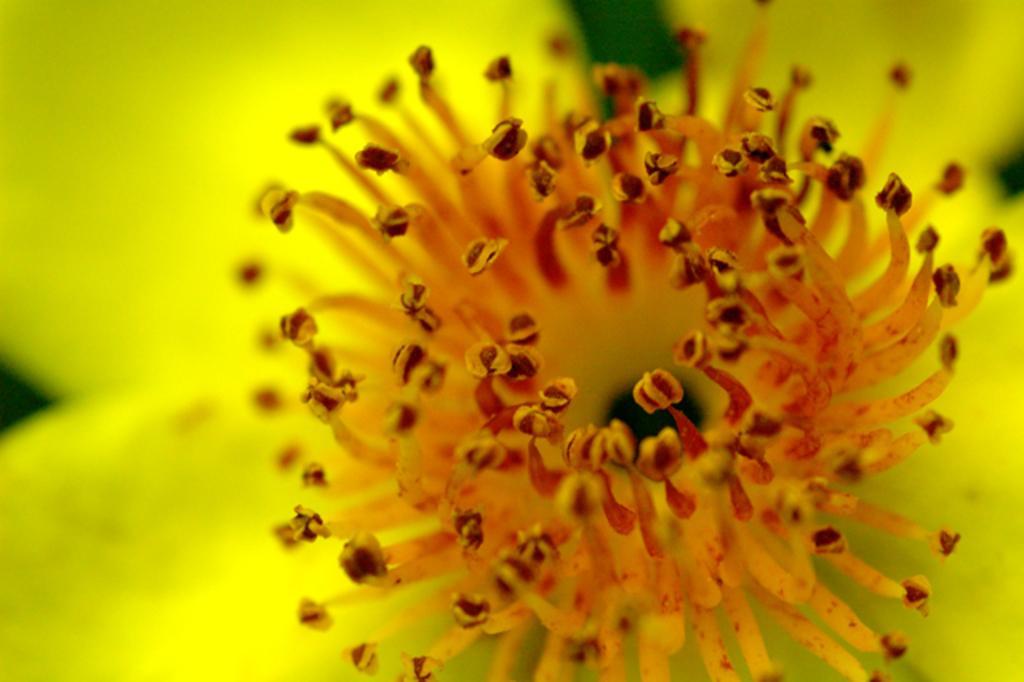Could you give a brief overview of what you see in this image? In this picture, we can see flower with blurred background. 